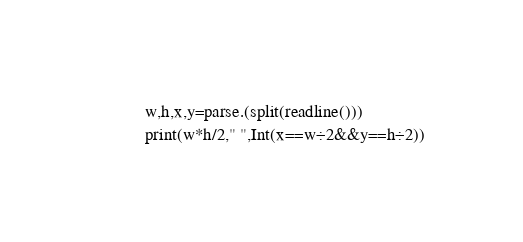<code> <loc_0><loc_0><loc_500><loc_500><_Julia_>w,h,x,y=parse.(split(readline()))
print(w*h/2," ",Int(x==w÷2&&y==h÷2))</code> 